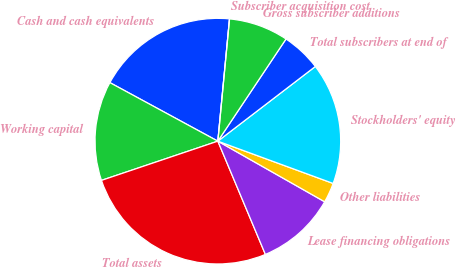<chart> <loc_0><loc_0><loc_500><loc_500><pie_chart><fcel>Cash and cash equivalents<fcel>Working capital<fcel>Total assets<fcel>Lease financing obligations<fcel>Other liabilities<fcel>Stockholders' equity<fcel>Total subscribers at end of<fcel>Gross subscriber additions<fcel>Subscriber acquisition cost<nl><fcel>18.61%<fcel>13.08%<fcel>26.15%<fcel>10.46%<fcel>2.62%<fcel>16.0%<fcel>5.23%<fcel>7.85%<fcel>0.0%<nl></chart> 